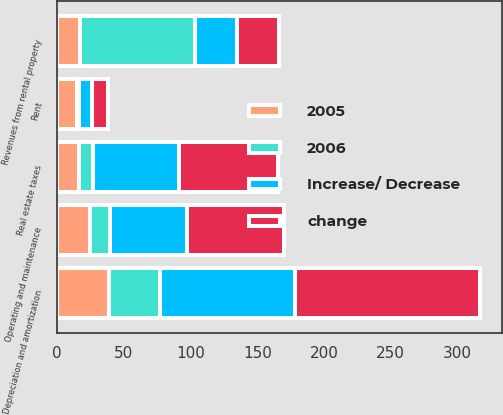Convert chart. <chart><loc_0><loc_0><loc_500><loc_500><stacked_bar_chart><ecel><fcel>Revenues from rental property<fcel>Rent<fcel>Real estate taxes<fcel>Operating and maintenance<fcel>Depreciation and amortization<nl><fcel>change<fcel>31.75<fcel>11.5<fcel>74.6<fcel>72.7<fcel>139.3<nl><fcel>Increase/ Decrease<fcel>31.75<fcel>10<fcel>64.1<fcel>58.2<fcel>100.5<nl><fcel>2006<fcel>85.9<fcel>1.5<fcel>10.5<fcel>14.5<fcel>38.8<nl><fcel>2005<fcel>17.1<fcel>15<fcel>16.4<fcel>24.9<fcel>38.6<nl></chart> 